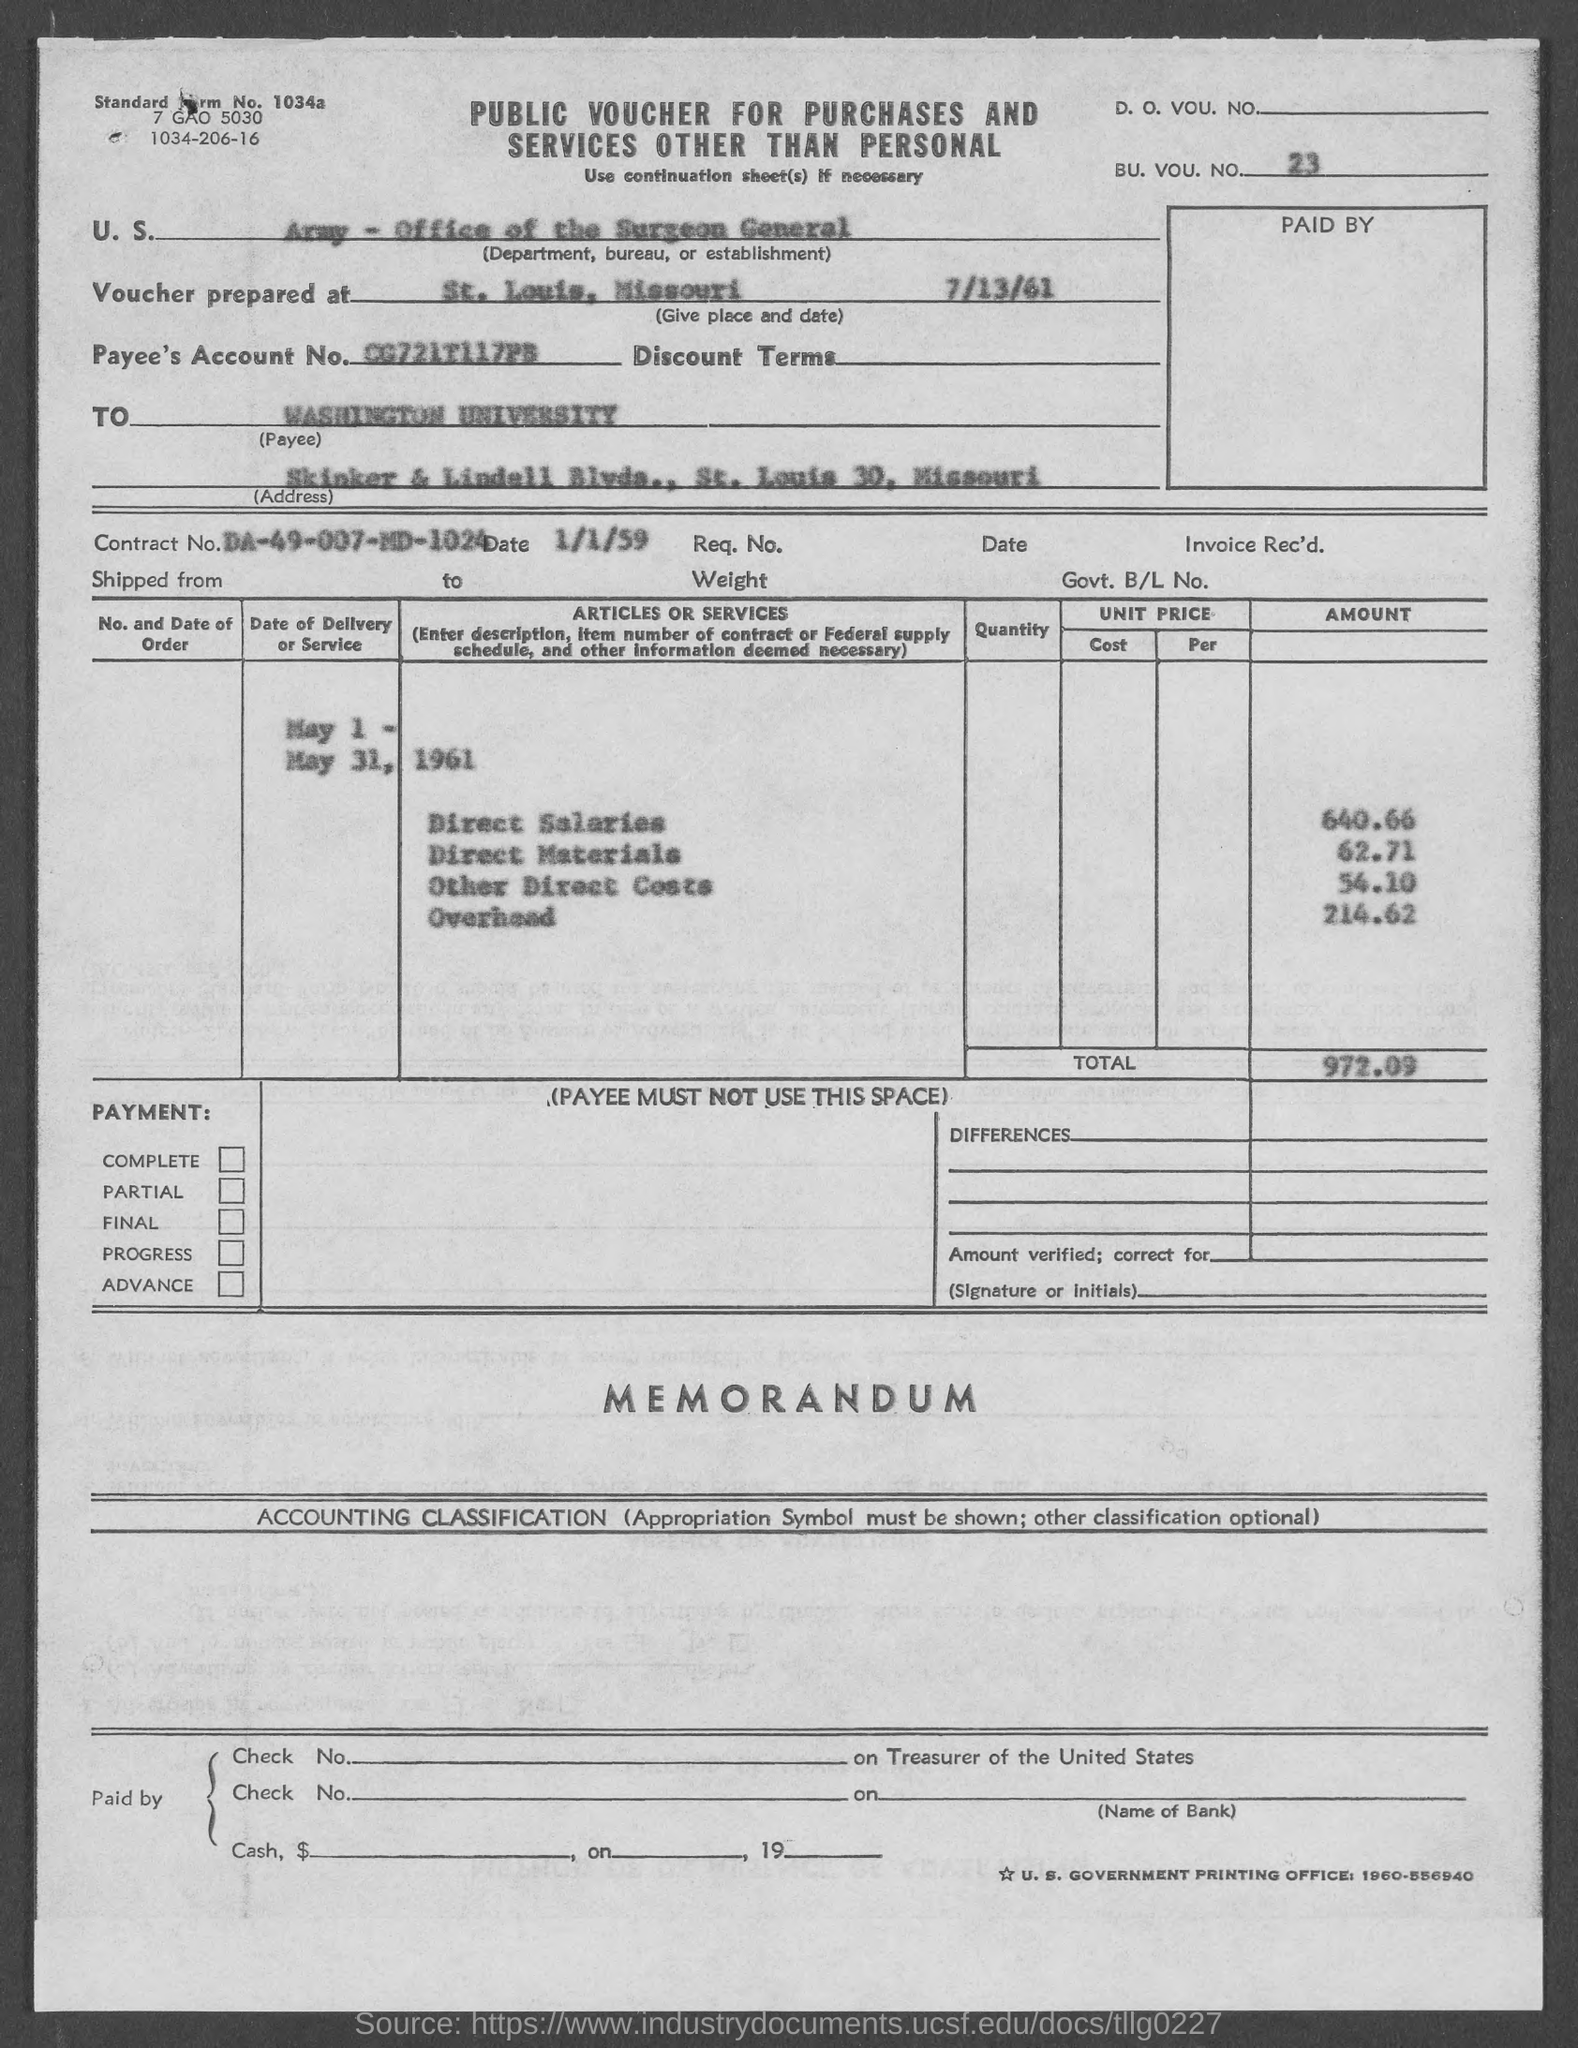Indicate a few pertinent items in this graphic. The contract number mentioned in the given form is DA-49-007-MD-1024. The total amount mentioned in the given form is 972.09 cents. The BU. VOC. NO. mentioned in the given form is 23. The direct materials amount mentioned in the given form is 62.71... The amount for direct salaries, as mentioned in the provided form, is 640.66... 